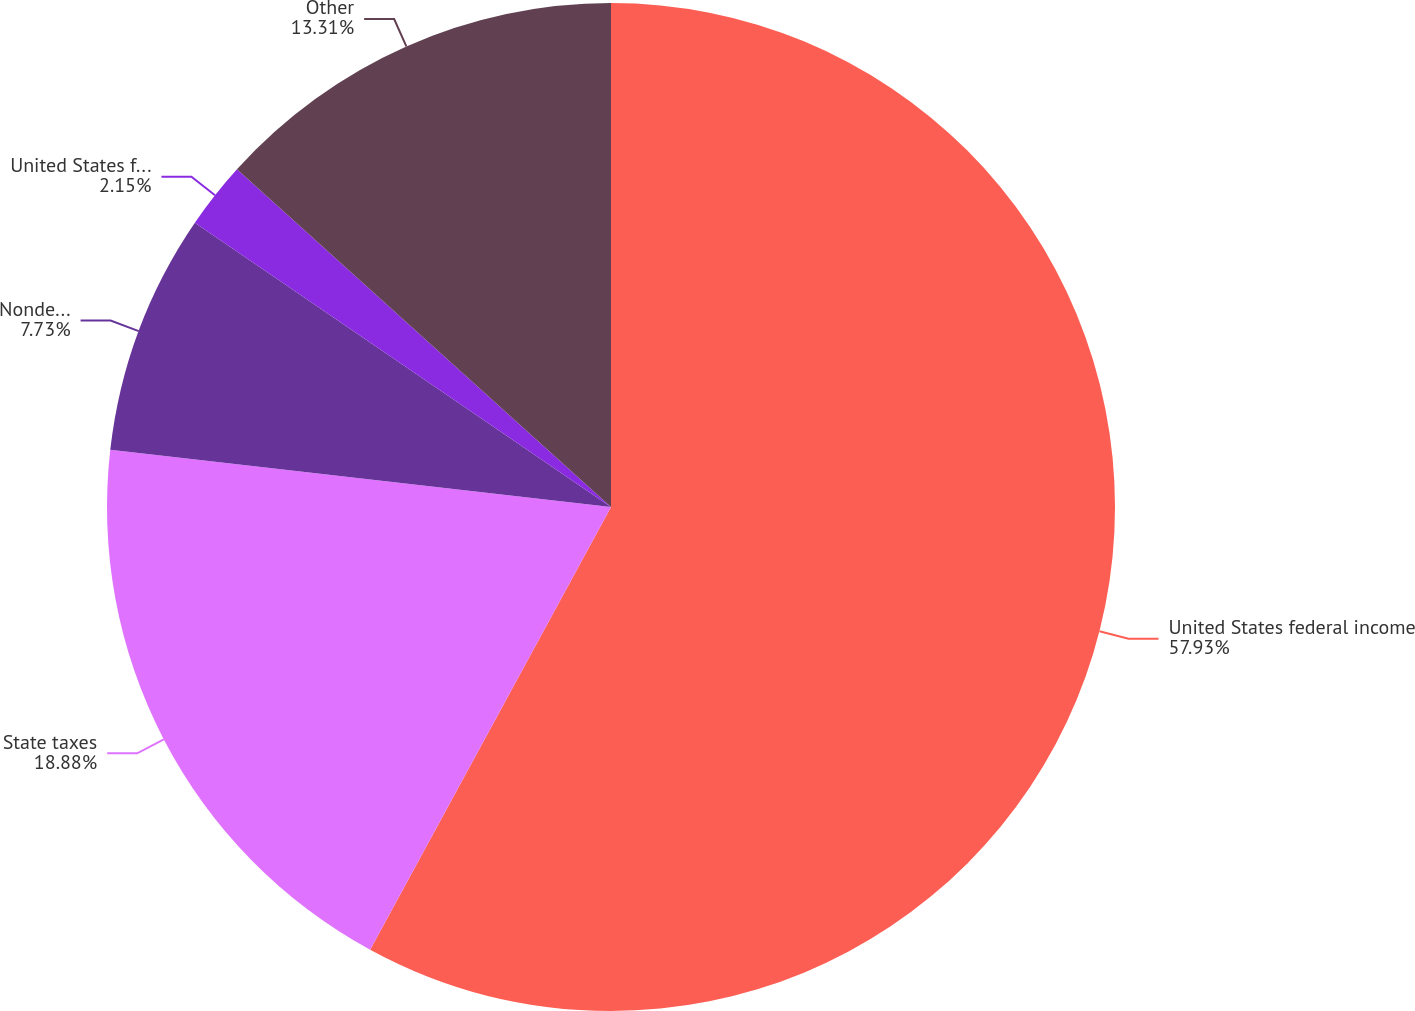Convert chart to OTSL. <chart><loc_0><loc_0><loc_500><loc_500><pie_chart><fcel>United States federal income<fcel>State taxes<fcel>Nondeductible stock-based<fcel>United States federal and<fcel>Other<nl><fcel>57.93%<fcel>18.88%<fcel>7.73%<fcel>2.15%<fcel>13.31%<nl></chart> 